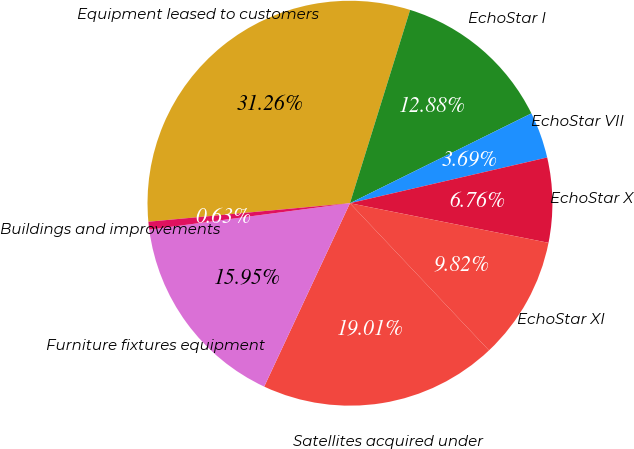Convert chart. <chart><loc_0><loc_0><loc_500><loc_500><pie_chart><fcel>Equipment leased to customers<fcel>EchoStar I<fcel>EchoStar VII<fcel>EchoStar X<fcel>EchoStar XI<fcel>Satellites acquired under<fcel>Furniture fixtures equipment<fcel>Buildings and improvements<nl><fcel>31.26%<fcel>12.88%<fcel>3.69%<fcel>6.76%<fcel>9.82%<fcel>19.01%<fcel>15.95%<fcel>0.63%<nl></chart> 